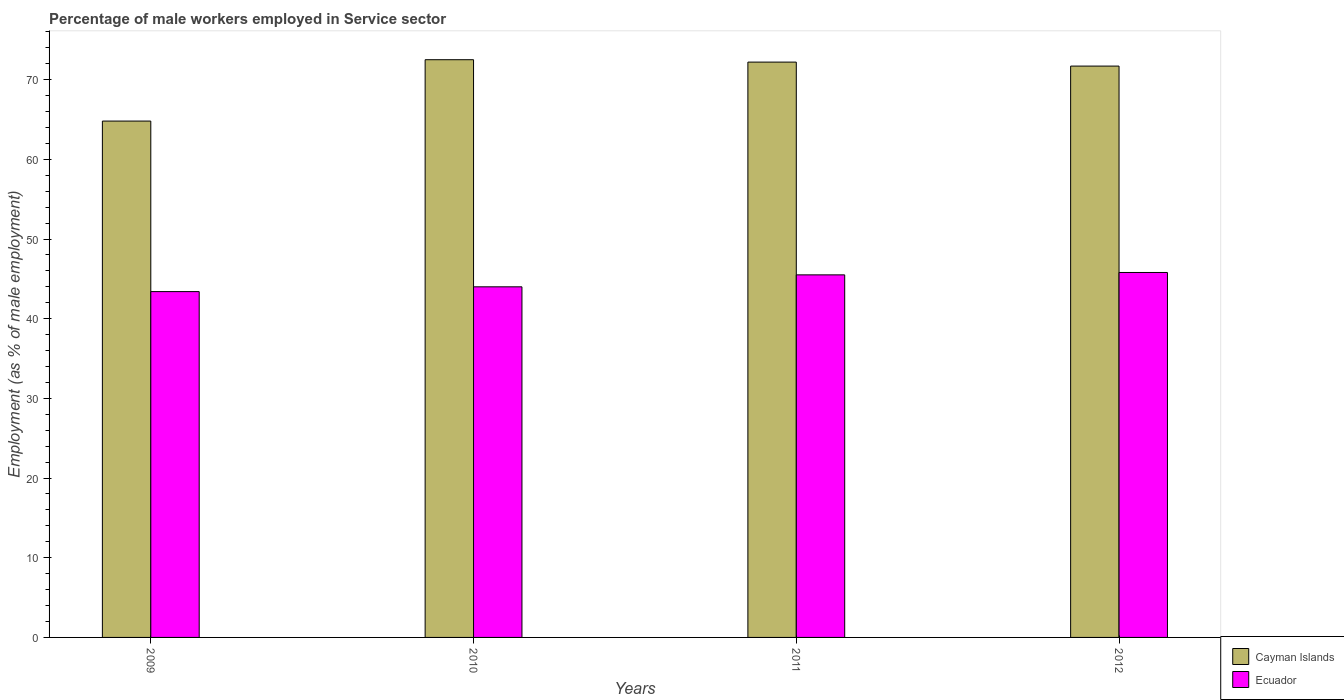How many bars are there on the 2nd tick from the right?
Provide a succinct answer. 2. What is the percentage of male workers employed in Service sector in Ecuador in 2009?
Provide a short and direct response. 43.4. Across all years, what is the maximum percentage of male workers employed in Service sector in Ecuador?
Offer a very short reply. 45.8. Across all years, what is the minimum percentage of male workers employed in Service sector in Ecuador?
Offer a very short reply. 43.4. What is the total percentage of male workers employed in Service sector in Cayman Islands in the graph?
Offer a very short reply. 281.2. What is the difference between the percentage of male workers employed in Service sector in Cayman Islands in 2009 and that in 2011?
Your answer should be compact. -7.4. What is the difference between the percentage of male workers employed in Service sector in Cayman Islands in 2010 and the percentage of male workers employed in Service sector in Ecuador in 2012?
Your answer should be compact. 26.7. What is the average percentage of male workers employed in Service sector in Ecuador per year?
Make the answer very short. 44.68. In the year 2011, what is the difference between the percentage of male workers employed in Service sector in Cayman Islands and percentage of male workers employed in Service sector in Ecuador?
Keep it short and to the point. 26.7. What is the ratio of the percentage of male workers employed in Service sector in Cayman Islands in 2010 to that in 2012?
Ensure brevity in your answer.  1.01. Is the percentage of male workers employed in Service sector in Cayman Islands in 2010 less than that in 2012?
Give a very brief answer. No. Is the difference between the percentage of male workers employed in Service sector in Cayman Islands in 2011 and 2012 greater than the difference between the percentage of male workers employed in Service sector in Ecuador in 2011 and 2012?
Provide a short and direct response. Yes. What is the difference between the highest and the second highest percentage of male workers employed in Service sector in Cayman Islands?
Provide a short and direct response. 0.3. What is the difference between the highest and the lowest percentage of male workers employed in Service sector in Cayman Islands?
Offer a terse response. 7.7. In how many years, is the percentage of male workers employed in Service sector in Cayman Islands greater than the average percentage of male workers employed in Service sector in Cayman Islands taken over all years?
Your response must be concise. 3. Is the sum of the percentage of male workers employed in Service sector in Ecuador in 2009 and 2011 greater than the maximum percentage of male workers employed in Service sector in Cayman Islands across all years?
Give a very brief answer. Yes. What does the 2nd bar from the left in 2009 represents?
Give a very brief answer. Ecuador. What does the 2nd bar from the right in 2012 represents?
Keep it short and to the point. Cayman Islands. Are all the bars in the graph horizontal?
Your answer should be compact. No. How many years are there in the graph?
Make the answer very short. 4. What is the difference between two consecutive major ticks on the Y-axis?
Provide a succinct answer. 10. Does the graph contain any zero values?
Ensure brevity in your answer.  No. How many legend labels are there?
Provide a succinct answer. 2. What is the title of the graph?
Offer a terse response. Percentage of male workers employed in Service sector. What is the label or title of the X-axis?
Provide a succinct answer. Years. What is the label or title of the Y-axis?
Ensure brevity in your answer.  Employment (as % of male employment). What is the Employment (as % of male employment) in Cayman Islands in 2009?
Give a very brief answer. 64.8. What is the Employment (as % of male employment) of Ecuador in 2009?
Make the answer very short. 43.4. What is the Employment (as % of male employment) of Cayman Islands in 2010?
Provide a short and direct response. 72.5. What is the Employment (as % of male employment) of Cayman Islands in 2011?
Offer a terse response. 72.2. What is the Employment (as % of male employment) of Ecuador in 2011?
Keep it short and to the point. 45.5. What is the Employment (as % of male employment) of Cayman Islands in 2012?
Give a very brief answer. 71.7. What is the Employment (as % of male employment) of Ecuador in 2012?
Ensure brevity in your answer.  45.8. Across all years, what is the maximum Employment (as % of male employment) of Cayman Islands?
Keep it short and to the point. 72.5. Across all years, what is the maximum Employment (as % of male employment) in Ecuador?
Ensure brevity in your answer.  45.8. Across all years, what is the minimum Employment (as % of male employment) of Cayman Islands?
Provide a short and direct response. 64.8. Across all years, what is the minimum Employment (as % of male employment) in Ecuador?
Your response must be concise. 43.4. What is the total Employment (as % of male employment) in Cayman Islands in the graph?
Provide a succinct answer. 281.2. What is the total Employment (as % of male employment) in Ecuador in the graph?
Ensure brevity in your answer.  178.7. What is the difference between the Employment (as % of male employment) of Cayman Islands in 2009 and that in 2010?
Make the answer very short. -7.7. What is the difference between the Employment (as % of male employment) of Ecuador in 2009 and that in 2010?
Ensure brevity in your answer.  -0.6. What is the difference between the Employment (as % of male employment) in Ecuador in 2009 and that in 2011?
Your response must be concise. -2.1. What is the difference between the Employment (as % of male employment) of Cayman Islands in 2009 and that in 2012?
Offer a terse response. -6.9. What is the difference between the Employment (as % of male employment) in Cayman Islands in 2010 and that in 2011?
Your answer should be very brief. 0.3. What is the difference between the Employment (as % of male employment) in Ecuador in 2010 and that in 2011?
Your answer should be compact. -1.5. What is the difference between the Employment (as % of male employment) in Ecuador in 2011 and that in 2012?
Offer a very short reply. -0.3. What is the difference between the Employment (as % of male employment) of Cayman Islands in 2009 and the Employment (as % of male employment) of Ecuador in 2010?
Ensure brevity in your answer.  20.8. What is the difference between the Employment (as % of male employment) in Cayman Islands in 2009 and the Employment (as % of male employment) in Ecuador in 2011?
Provide a succinct answer. 19.3. What is the difference between the Employment (as % of male employment) of Cayman Islands in 2009 and the Employment (as % of male employment) of Ecuador in 2012?
Keep it short and to the point. 19. What is the difference between the Employment (as % of male employment) in Cayman Islands in 2010 and the Employment (as % of male employment) in Ecuador in 2012?
Offer a very short reply. 26.7. What is the difference between the Employment (as % of male employment) of Cayman Islands in 2011 and the Employment (as % of male employment) of Ecuador in 2012?
Offer a terse response. 26.4. What is the average Employment (as % of male employment) in Cayman Islands per year?
Your response must be concise. 70.3. What is the average Employment (as % of male employment) of Ecuador per year?
Ensure brevity in your answer.  44.67. In the year 2009, what is the difference between the Employment (as % of male employment) of Cayman Islands and Employment (as % of male employment) of Ecuador?
Keep it short and to the point. 21.4. In the year 2011, what is the difference between the Employment (as % of male employment) of Cayman Islands and Employment (as % of male employment) of Ecuador?
Keep it short and to the point. 26.7. In the year 2012, what is the difference between the Employment (as % of male employment) in Cayman Islands and Employment (as % of male employment) in Ecuador?
Make the answer very short. 25.9. What is the ratio of the Employment (as % of male employment) of Cayman Islands in 2009 to that in 2010?
Your answer should be compact. 0.89. What is the ratio of the Employment (as % of male employment) of Ecuador in 2009 to that in 2010?
Offer a terse response. 0.99. What is the ratio of the Employment (as % of male employment) in Cayman Islands in 2009 to that in 2011?
Provide a short and direct response. 0.9. What is the ratio of the Employment (as % of male employment) in Ecuador in 2009 to that in 2011?
Provide a succinct answer. 0.95. What is the ratio of the Employment (as % of male employment) in Cayman Islands in 2009 to that in 2012?
Your response must be concise. 0.9. What is the ratio of the Employment (as % of male employment) in Ecuador in 2009 to that in 2012?
Ensure brevity in your answer.  0.95. What is the ratio of the Employment (as % of male employment) of Ecuador in 2010 to that in 2011?
Your answer should be very brief. 0.97. What is the ratio of the Employment (as % of male employment) of Cayman Islands in 2010 to that in 2012?
Provide a short and direct response. 1.01. What is the ratio of the Employment (as % of male employment) of Ecuador in 2010 to that in 2012?
Provide a short and direct response. 0.96. What is the difference between the highest and the second highest Employment (as % of male employment) of Cayman Islands?
Offer a very short reply. 0.3. What is the difference between the highest and the lowest Employment (as % of male employment) in Cayman Islands?
Provide a succinct answer. 7.7. 